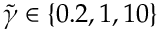Convert formula to latex. <formula><loc_0><loc_0><loc_500><loc_500>\tilde { \gamma } \in \{ 0 . 2 , 1 , 1 0 \}</formula> 